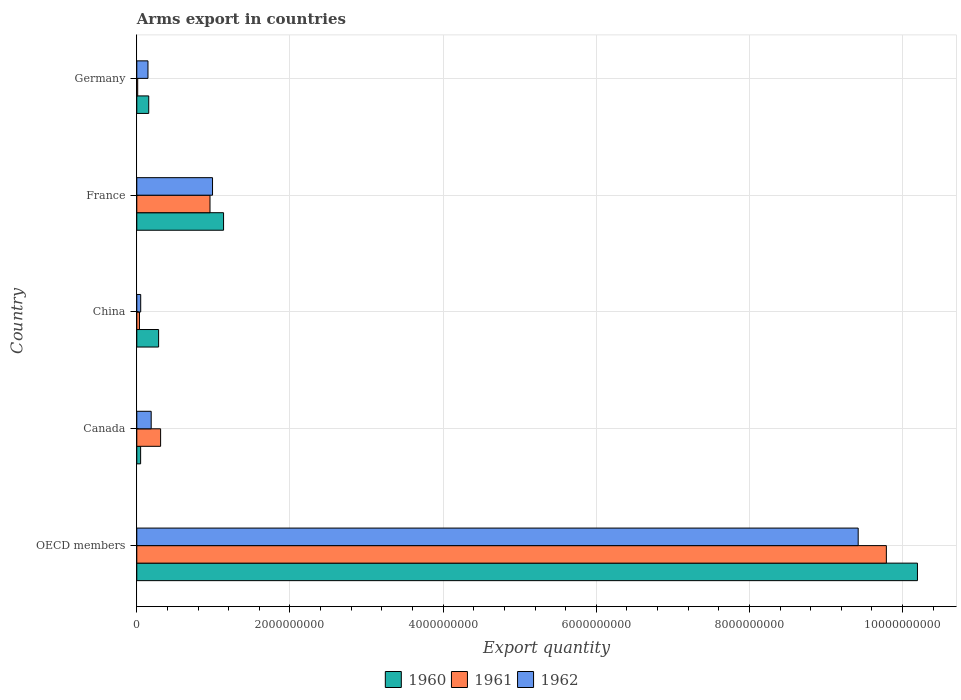How many different coloured bars are there?
Your response must be concise. 3. Are the number of bars per tick equal to the number of legend labels?
Provide a short and direct response. Yes. In how many cases, is the number of bars for a given country not equal to the number of legend labels?
Offer a terse response. 0. What is the total arms export in 1962 in Germany?
Ensure brevity in your answer.  1.46e+08. Across all countries, what is the maximum total arms export in 1961?
Make the answer very short. 9.79e+09. In which country was the total arms export in 1962 maximum?
Your answer should be very brief. OECD members. What is the total total arms export in 1962 in the graph?
Provide a short and direct response. 1.08e+1. What is the difference between the total arms export in 1962 in Germany and that in OECD members?
Offer a terse response. -9.27e+09. What is the difference between the total arms export in 1961 in France and the total arms export in 1962 in OECD members?
Provide a succinct answer. -8.46e+09. What is the average total arms export in 1960 per country?
Ensure brevity in your answer.  2.36e+09. What is the difference between the total arms export in 1962 and total arms export in 1961 in Canada?
Make the answer very short. -1.23e+08. What is the ratio of the total arms export in 1960 in Germany to that in OECD members?
Keep it short and to the point. 0.02. Is the difference between the total arms export in 1962 in China and OECD members greater than the difference between the total arms export in 1961 in China and OECD members?
Make the answer very short. Yes. What is the difference between the highest and the second highest total arms export in 1960?
Your response must be concise. 9.06e+09. What is the difference between the highest and the lowest total arms export in 1962?
Offer a terse response. 9.37e+09. What does the 3rd bar from the bottom in Canada represents?
Give a very brief answer. 1962. How many bars are there?
Your answer should be compact. 15. Are all the bars in the graph horizontal?
Ensure brevity in your answer.  Yes. Does the graph contain any zero values?
Your response must be concise. No. Does the graph contain grids?
Give a very brief answer. Yes. Where does the legend appear in the graph?
Keep it short and to the point. Bottom center. How many legend labels are there?
Your answer should be very brief. 3. How are the legend labels stacked?
Your response must be concise. Horizontal. What is the title of the graph?
Give a very brief answer. Arms export in countries. What is the label or title of the X-axis?
Make the answer very short. Export quantity. What is the Export quantity of 1960 in OECD members?
Provide a short and direct response. 1.02e+1. What is the Export quantity in 1961 in OECD members?
Provide a short and direct response. 9.79e+09. What is the Export quantity of 1962 in OECD members?
Provide a succinct answer. 9.42e+09. What is the Export quantity of 1960 in Canada?
Provide a short and direct response. 5.00e+07. What is the Export quantity of 1961 in Canada?
Keep it short and to the point. 3.11e+08. What is the Export quantity of 1962 in Canada?
Offer a very short reply. 1.88e+08. What is the Export quantity of 1960 in China?
Offer a very short reply. 2.85e+08. What is the Export quantity of 1961 in China?
Offer a very short reply. 3.50e+07. What is the Export quantity of 1962 in China?
Provide a short and direct response. 5.10e+07. What is the Export quantity of 1960 in France?
Keep it short and to the point. 1.13e+09. What is the Export quantity of 1961 in France?
Your answer should be compact. 9.56e+08. What is the Export quantity of 1962 in France?
Give a very brief answer. 9.89e+08. What is the Export quantity of 1960 in Germany?
Your response must be concise. 1.56e+08. What is the Export quantity in 1962 in Germany?
Provide a succinct answer. 1.46e+08. Across all countries, what is the maximum Export quantity of 1960?
Make the answer very short. 1.02e+1. Across all countries, what is the maximum Export quantity in 1961?
Your answer should be compact. 9.79e+09. Across all countries, what is the maximum Export quantity in 1962?
Provide a succinct answer. 9.42e+09. Across all countries, what is the minimum Export quantity of 1960?
Keep it short and to the point. 5.00e+07. Across all countries, what is the minimum Export quantity in 1962?
Make the answer very short. 5.10e+07. What is the total Export quantity in 1960 in the graph?
Provide a short and direct response. 1.18e+1. What is the total Export quantity of 1961 in the graph?
Provide a succinct answer. 1.11e+1. What is the total Export quantity in 1962 in the graph?
Your answer should be compact. 1.08e+1. What is the difference between the Export quantity of 1960 in OECD members and that in Canada?
Your answer should be compact. 1.01e+1. What is the difference between the Export quantity in 1961 in OECD members and that in Canada?
Give a very brief answer. 9.48e+09. What is the difference between the Export quantity of 1962 in OECD members and that in Canada?
Your answer should be compact. 9.23e+09. What is the difference between the Export quantity of 1960 in OECD members and that in China?
Offer a terse response. 9.91e+09. What is the difference between the Export quantity of 1961 in OECD members and that in China?
Ensure brevity in your answer.  9.75e+09. What is the difference between the Export quantity of 1962 in OECD members and that in China?
Ensure brevity in your answer.  9.37e+09. What is the difference between the Export quantity of 1960 in OECD members and that in France?
Your answer should be compact. 9.06e+09. What is the difference between the Export quantity of 1961 in OECD members and that in France?
Your response must be concise. 8.83e+09. What is the difference between the Export quantity in 1962 in OECD members and that in France?
Provide a short and direct response. 8.43e+09. What is the difference between the Export quantity in 1960 in OECD members and that in Germany?
Provide a succinct answer. 1.00e+1. What is the difference between the Export quantity in 1961 in OECD members and that in Germany?
Your answer should be compact. 9.78e+09. What is the difference between the Export quantity of 1962 in OECD members and that in Germany?
Provide a succinct answer. 9.27e+09. What is the difference between the Export quantity in 1960 in Canada and that in China?
Your answer should be very brief. -2.35e+08. What is the difference between the Export quantity of 1961 in Canada and that in China?
Your answer should be very brief. 2.76e+08. What is the difference between the Export quantity of 1962 in Canada and that in China?
Offer a very short reply. 1.37e+08. What is the difference between the Export quantity in 1960 in Canada and that in France?
Offer a very short reply. -1.08e+09. What is the difference between the Export quantity in 1961 in Canada and that in France?
Make the answer very short. -6.45e+08. What is the difference between the Export quantity in 1962 in Canada and that in France?
Your response must be concise. -8.01e+08. What is the difference between the Export quantity of 1960 in Canada and that in Germany?
Provide a succinct answer. -1.06e+08. What is the difference between the Export quantity in 1961 in Canada and that in Germany?
Offer a very short reply. 2.99e+08. What is the difference between the Export quantity of 1962 in Canada and that in Germany?
Ensure brevity in your answer.  4.20e+07. What is the difference between the Export quantity of 1960 in China and that in France?
Offer a very short reply. -8.48e+08. What is the difference between the Export quantity of 1961 in China and that in France?
Your answer should be very brief. -9.21e+08. What is the difference between the Export quantity of 1962 in China and that in France?
Provide a short and direct response. -9.38e+08. What is the difference between the Export quantity in 1960 in China and that in Germany?
Offer a very short reply. 1.29e+08. What is the difference between the Export quantity in 1961 in China and that in Germany?
Offer a very short reply. 2.30e+07. What is the difference between the Export quantity in 1962 in China and that in Germany?
Provide a short and direct response. -9.50e+07. What is the difference between the Export quantity of 1960 in France and that in Germany?
Keep it short and to the point. 9.77e+08. What is the difference between the Export quantity of 1961 in France and that in Germany?
Provide a succinct answer. 9.44e+08. What is the difference between the Export quantity of 1962 in France and that in Germany?
Provide a short and direct response. 8.43e+08. What is the difference between the Export quantity of 1960 in OECD members and the Export quantity of 1961 in Canada?
Offer a terse response. 9.88e+09. What is the difference between the Export quantity in 1960 in OECD members and the Export quantity in 1962 in Canada?
Offer a terse response. 1.00e+1. What is the difference between the Export quantity in 1961 in OECD members and the Export quantity in 1962 in Canada?
Make the answer very short. 9.60e+09. What is the difference between the Export quantity in 1960 in OECD members and the Export quantity in 1961 in China?
Give a very brief answer. 1.02e+1. What is the difference between the Export quantity of 1960 in OECD members and the Export quantity of 1962 in China?
Your answer should be compact. 1.01e+1. What is the difference between the Export quantity in 1961 in OECD members and the Export quantity in 1962 in China?
Offer a very short reply. 9.74e+09. What is the difference between the Export quantity of 1960 in OECD members and the Export quantity of 1961 in France?
Keep it short and to the point. 9.24e+09. What is the difference between the Export quantity in 1960 in OECD members and the Export quantity in 1962 in France?
Offer a terse response. 9.20e+09. What is the difference between the Export quantity in 1961 in OECD members and the Export quantity in 1962 in France?
Your answer should be very brief. 8.80e+09. What is the difference between the Export quantity in 1960 in OECD members and the Export quantity in 1961 in Germany?
Make the answer very short. 1.02e+1. What is the difference between the Export quantity in 1960 in OECD members and the Export quantity in 1962 in Germany?
Provide a short and direct response. 1.00e+1. What is the difference between the Export quantity of 1961 in OECD members and the Export quantity of 1962 in Germany?
Ensure brevity in your answer.  9.64e+09. What is the difference between the Export quantity of 1960 in Canada and the Export quantity of 1961 in China?
Keep it short and to the point. 1.50e+07. What is the difference between the Export quantity of 1960 in Canada and the Export quantity of 1962 in China?
Ensure brevity in your answer.  -1.00e+06. What is the difference between the Export quantity of 1961 in Canada and the Export quantity of 1962 in China?
Ensure brevity in your answer.  2.60e+08. What is the difference between the Export quantity of 1960 in Canada and the Export quantity of 1961 in France?
Your answer should be compact. -9.06e+08. What is the difference between the Export quantity of 1960 in Canada and the Export quantity of 1962 in France?
Give a very brief answer. -9.39e+08. What is the difference between the Export quantity of 1961 in Canada and the Export quantity of 1962 in France?
Offer a terse response. -6.78e+08. What is the difference between the Export quantity of 1960 in Canada and the Export quantity of 1961 in Germany?
Give a very brief answer. 3.80e+07. What is the difference between the Export quantity of 1960 in Canada and the Export quantity of 1962 in Germany?
Offer a terse response. -9.60e+07. What is the difference between the Export quantity of 1961 in Canada and the Export quantity of 1962 in Germany?
Your answer should be compact. 1.65e+08. What is the difference between the Export quantity in 1960 in China and the Export quantity in 1961 in France?
Your response must be concise. -6.71e+08. What is the difference between the Export quantity in 1960 in China and the Export quantity in 1962 in France?
Provide a short and direct response. -7.04e+08. What is the difference between the Export quantity in 1961 in China and the Export quantity in 1962 in France?
Give a very brief answer. -9.54e+08. What is the difference between the Export quantity of 1960 in China and the Export quantity of 1961 in Germany?
Offer a very short reply. 2.73e+08. What is the difference between the Export quantity in 1960 in China and the Export quantity in 1962 in Germany?
Ensure brevity in your answer.  1.39e+08. What is the difference between the Export quantity in 1961 in China and the Export quantity in 1962 in Germany?
Give a very brief answer. -1.11e+08. What is the difference between the Export quantity in 1960 in France and the Export quantity in 1961 in Germany?
Your response must be concise. 1.12e+09. What is the difference between the Export quantity in 1960 in France and the Export quantity in 1962 in Germany?
Keep it short and to the point. 9.87e+08. What is the difference between the Export quantity in 1961 in France and the Export quantity in 1962 in Germany?
Give a very brief answer. 8.10e+08. What is the average Export quantity in 1960 per country?
Your answer should be compact. 2.36e+09. What is the average Export quantity of 1961 per country?
Ensure brevity in your answer.  2.22e+09. What is the average Export quantity in 1962 per country?
Provide a succinct answer. 2.16e+09. What is the difference between the Export quantity in 1960 and Export quantity in 1961 in OECD members?
Your response must be concise. 4.06e+08. What is the difference between the Export quantity in 1960 and Export quantity in 1962 in OECD members?
Your response must be concise. 7.74e+08. What is the difference between the Export quantity in 1961 and Export quantity in 1962 in OECD members?
Provide a succinct answer. 3.68e+08. What is the difference between the Export quantity in 1960 and Export quantity in 1961 in Canada?
Ensure brevity in your answer.  -2.61e+08. What is the difference between the Export quantity of 1960 and Export quantity of 1962 in Canada?
Make the answer very short. -1.38e+08. What is the difference between the Export quantity in 1961 and Export quantity in 1962 in Canada?
Your answer should be very brief. 1.23e+08. What is the difference between the Export quantity in 1960 and Export quantity in 1961 in China?
Offer a terse response. 2.50e+08. What is the difference between the Export quantity of 1960 and Export quantity of 1962 in China?
Offer a terse response. 2.34e+08. What is the difference between the Export quantity in 1961 and Export quantity in 1962 in China?
Provide a succinct answer. -1.60e+07. What is the difference between the Export quantity of 1960 and Export quantity of 1961 in France?
Keep it short and to the point. 1.77e+08. What is the difference between the Export quantity of 1960 and Export quantity of 1962 in France?
Ensure brevity in your answer.  1.44e+08. What is the difference between the Export quantity in 1961 and Export quantity in 1962 in France?
Ensure brevity in your answer.  -3.30e+07. What is the difference between the Export quantity in 1960 and Export quantity in 1961 in Germany?
Provide a short and direct response. 1.44e+08. What is the difference between the Export quantity in 1961 and Export quantity in 1962 in Germany?
Give a very brief answer. -1.34e+08. What is the ratio of the Export quantity of 1960 in OECD members to that in Canada?
Make the answer very short. 203.88. What is the ratio of the Export quantity of 1961 in OECD members to that in Canada?
Make the answer very short. 31.47. What is the ratio of the Export quantity of 1962 in OECD members to that in Canada?
Your answer should be very brief. 50.11. What is the ratio of the Export quantity of 1960 in OECD members to that in China?
Offer a very short reply. 35.77. What is the ratio of the Export quantity of 1961 in OECD members to that in China?
Keep it short and to the point. 279.66. What is the ratio of the Export quantity in 1962 in OECD members to that in China?
Ensure brevity in your answer.  184.71. What is the ratio of the Export quantity of 1960 in OECD members to that in France?
Provide a succinct answer. 9. What is the ratio of the Export quantity in 1961 in OECD members to that in France?
Your response must be concise. 10.24. What is the ratio of the Export quantity in 1962 in OECD members to that in France?
Provide a short and direct response. 9.52. What is the ratio of the Export quantity of 1960 in OECD members to that in Germany?
Offer a very short reply. 65.35. What is the ratio of the Export quantity of 1961 in OECD members to that in Germany?
Make the answer very short. 815.67. What is the ratio of the Export quantity in 1962 in OECD members to that in Germany?
Your response must be concise. 64.52. What is the ratio of the Export quantity of 1960 in Canada to that in China?
Your answer should be very brief. 0.18. What is the ratio of the Export quantity of 1961 in Canada to that in China?
Ensure brevity in your answer.  8.89. What is the ratio of the Export quantity in 1962 in Canada to that in China?
Offer a terse response. 3.69. What is the ratio of the Export quantity of 1960 in Canada to that in France?
Offer a very short reply. 0.04. What is the ratio of the Export quantity in 1961 in Canada to that in France?
Offer a terse response. 0.33. What is the ratio of the Export quantity in 1962 in Canada to that in France?
Give a very brief answer. 0.19. What is the ratio of the Export quantity in 1960 in Canada to that in Germany?
Make the answer very short. 0.32. What is the ratio of the Export quantity of 1961 in Canada to that in Germany?
Your answer should be very brief. 25.92. What is the ratio of the Export quantity in 1962 in Canada to that in Germany?
Give a very brief answer. 1.29. What is the ratio of the Export quantity of 1960 in China to that in France?
Make the answer very short. 0.25. What is the ratio of the Export quantity of 1961 in China to that in France?
Your answer should be compact. 0.04. What is the ratio of the Export quantity in 1962 in China to that in France?
Provide a succinct answer. 0.05. What is the ratio of the Export quantity of 1960 in China to that in Germany?
Your answer should be very brief. 1.83. What is the ratio of the Export quantity of 1961 in China to that in Germany?
Ensure brevity in your answer.  2.92. What is the ratio of the Export quantity in 1962 in China to that in Germany?
Give a very brief answer. 0.35. What is the ratio of the Export quantity of 1960 in France to that in Germany?
Your answer should be compact. 7.26. What is the ratio of the Export quantity of 1961 in France to that in Germany?
Keep it short and to the point. 79.67. What is the ratio of the Export quantity in 1962 in France to that in Germany?
Keep it short and to the point. 6.77. What is the difference between the highest and the second highest Export quantity in 1960?
Give a very brief answer. 9.06e+09. What is the difference between the highest and the second highest Export quantity of 1961?
Ensure brevity in your answer.  8.83e+09. What is the difference between the highest and the second highest Export quantity of 1962?
Provide a short and direct response. 8.43e+09. What is the difference between the highest and the lowest Export quantity in 1960?
Your answer should be compact. 1.01e+1. What is the difference between the highest and the lowest Export quantity of 1961?
Your response must be concise. 9.78e+09. What is the difference between the highest and the lowest Export quantity in 1962?
Ensure brevity in your answer.  9.37e+09. 